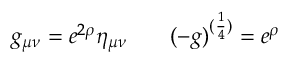<formula> <loc_0><loc_0><loc_500><loc_500>g _ { \mu \nu } = e ^ { 2 \rho } \eta _ { \mu \nu } \, ( - g ) ^ { ( { \frac { 1 } { 4 } } ) } = e ^ { \rho }</formula> 